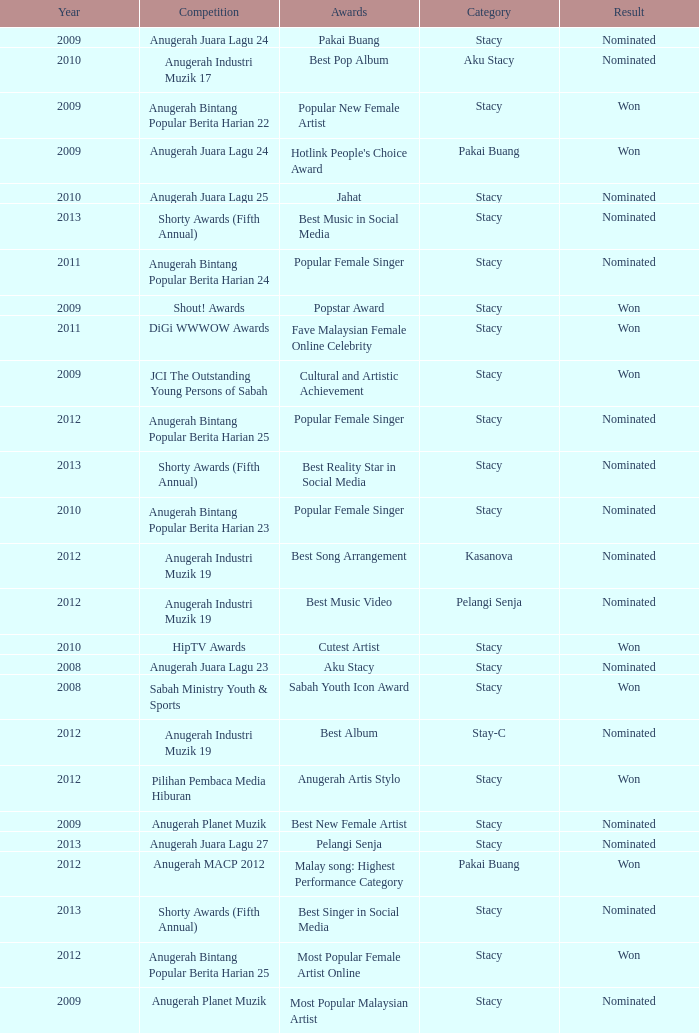What was the year that had Anugerah Bintang Popular Berita Harian 23 as competition? 1.0. 